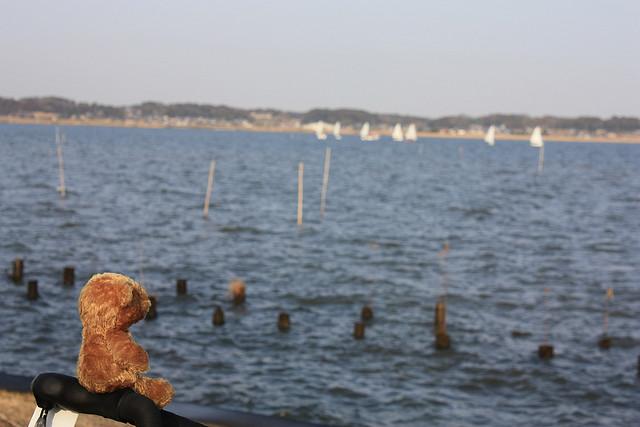Is it sunrise or sunset?
Answer briefly. Sunrise. What animal is on the boat?
Quick response, please. Bear. Is the teddy bear planning to swim in the sea?
Answer briefly. No. What color are the sails in the picture?
Give a very brief answer. White. What animal is shown?
Give a very brief answer. Teddy bear. What is the bear staring at?
Quick response, please. Water. Does this photo suggest a relationship of some longstanding?
Give a very brief answer. No. What animal is it?
Short answer required. Bear. Do they have protection from rain?
Write a very short answer. No. 